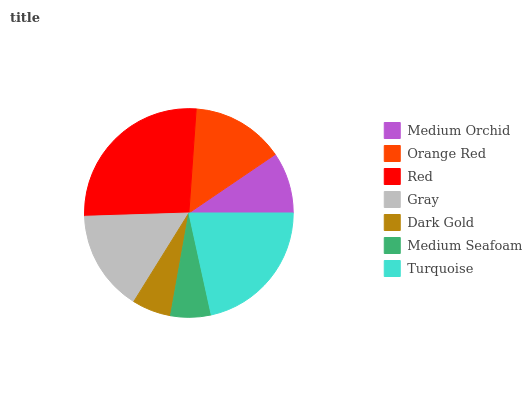Is Dark Gold the minimum?
Answer yes or no. Yes. Is Red the maximum?
Answer yes or no. Yes. Is Orange Red the minimum?
Answer yes or no. No. Is Orange Red the maximum?
Answer yes or no. No. Is Orange Red greater than Medium Orchid?
Answer yes or no. Yes. Is Medium Orchid less than Orange Red?
Answer yes or no. Yes. Is Medium Orchid greater than Orange Red?
Answer yes or no. No. Is Orange Red less than Medium Orchid?
Answer yes or no. No. Is Orange Red the high median?
Answer yes or no. Yes. Is Orange Red the low median?
Answer yes or no. Yes. Is Red the high median?
Answer yes or no. No. Is Turquoise the low median?
Answer yes or no. No. 